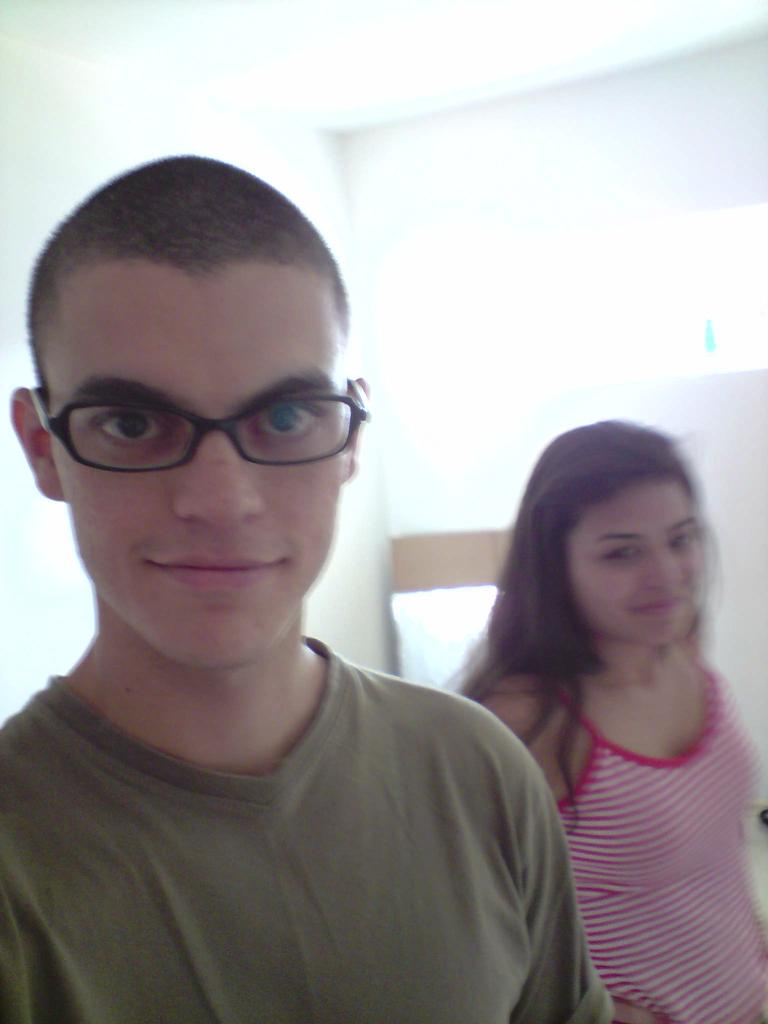What is the man wearing on the left side of the image? The man is wearing specs on the left side of the image. Who is on the right side of the image? There is a woman on the right side of the image. What color is the background of the image? The background of the image is white. What is the purpose of the baseball in the image? There is no baseball present in the image, so it is not possible to determine its purpose. 